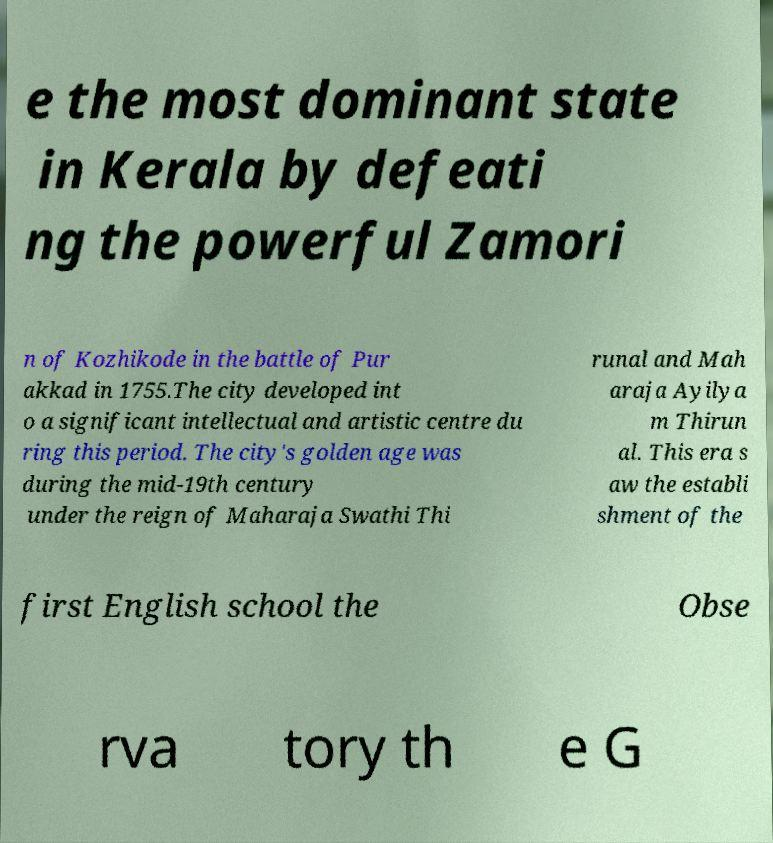What messages or text are displayed in this image? I need them in a readable, typed format. e the most dominant state in Kerala by defeati ng the powerful Zamori n of Kozhikode in the battle of Pur akkad in 1755.The city developed int o a significant intellectual and artistic centre du ring this period. The city's golden age was during the mid-19th century under the reign of Maharaja Swathi Thi runal and Mah araja Ayilya m Thirun al. This era s aw the establi shment of the first English school the Obse rva tory th e G 